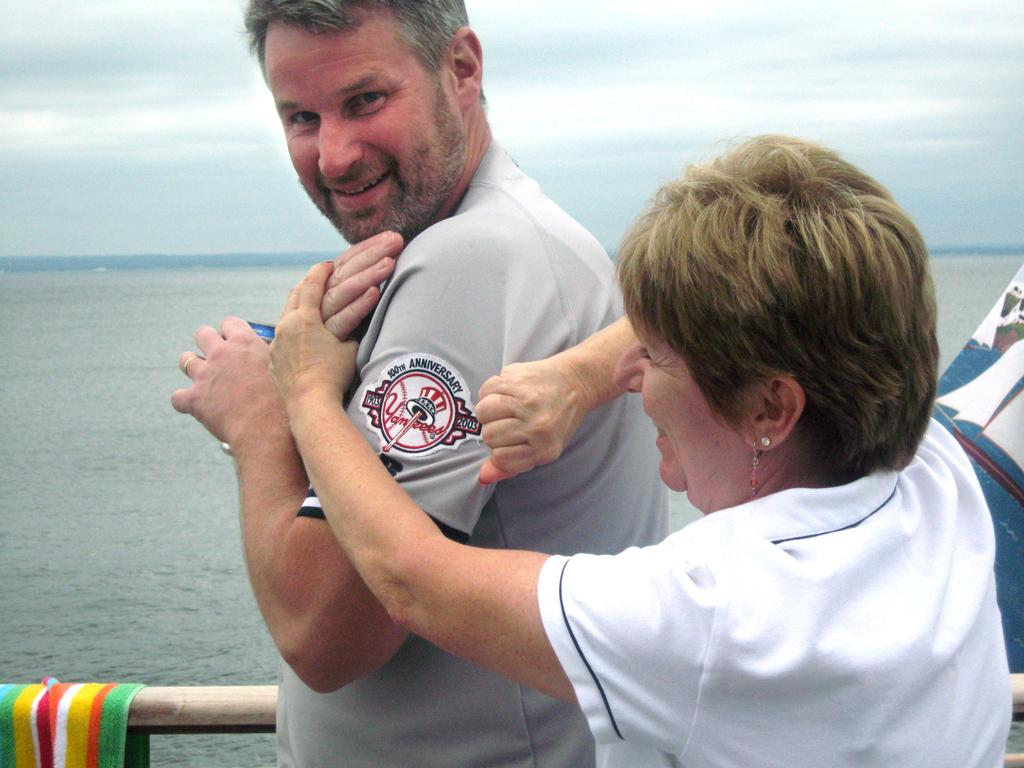<image>
Create a compact narrative representing the image presented. A woman stretches a man's sleeve, showing his Yankees patch. 